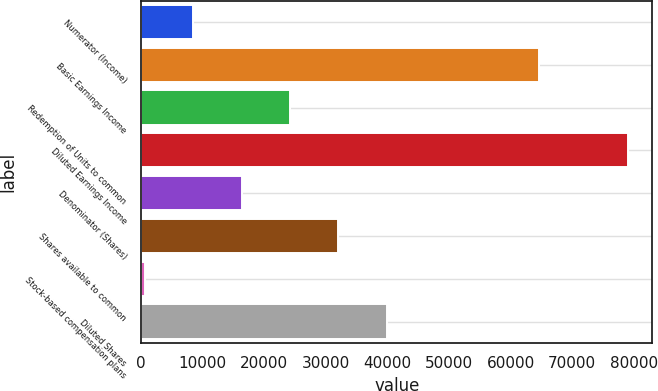<chart> <loc_0><loc_0><loc_500><loc_500><bar_chart><fcel>Numerator (Income)<fcel>Basic Earnings Income<fcel>Redemption of Units to common<fcel>Diluted Earnings Income<fcel>Denominator (Shares)<fcel>Shares available to common<fcel>Stock-based compensation plans<fcel>Diluted Shares<nl><fcel>8487<fcel>64641<fcel>24175<fcel>79083<fcel>16331<fcel>32019<fcel>643<fcel>39863<nl></chart> 